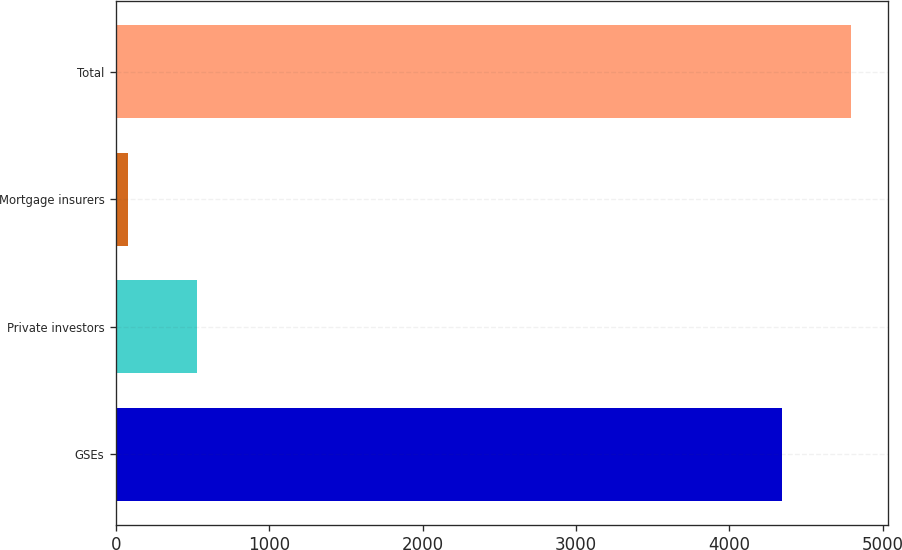Convert chart to OTSL. <chart><loc_0><loc_0><loc_500><loc_500><bar_chart><fcel>GSEs<fcel>Private investors<fcel>Mortgage insurers<fcel>Total<nl><fcel>4344<fcel>526.7<fcel>76<fcel>4794.7<nl></chart> 